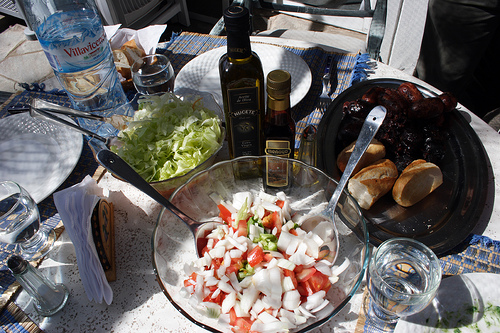<image>
Is the spoon above the food? Yes. The spoon is positioned above the food in the vertical space, higher up in the scene. 